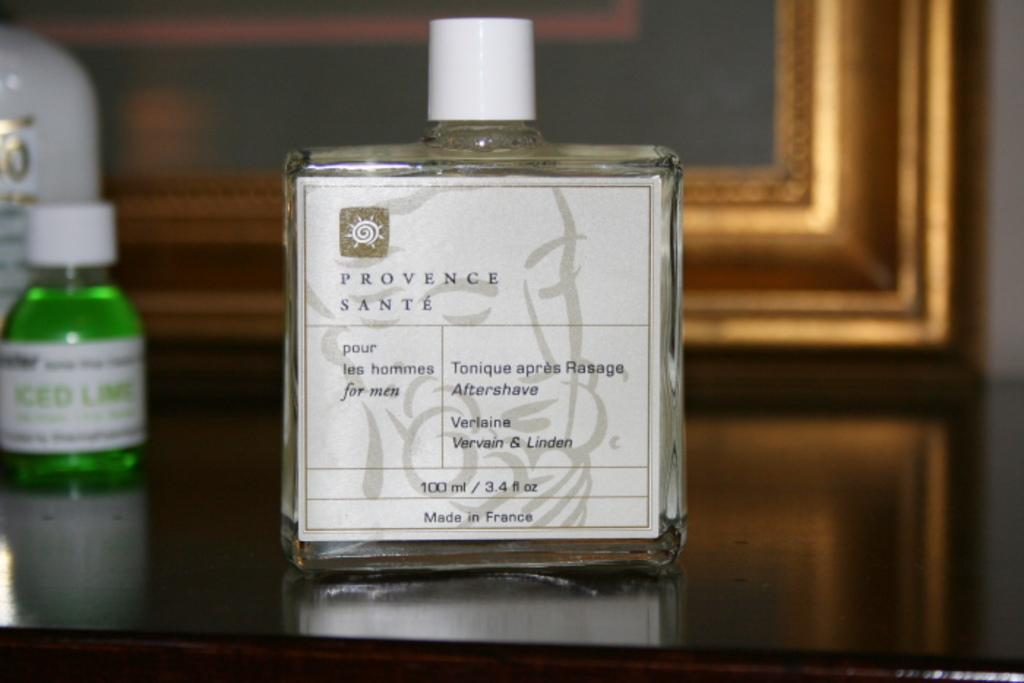<image>
Relay a brief, clear account of the picture shown. A bottle of Provence Sante for men displayed in front of a gold picture frame. 